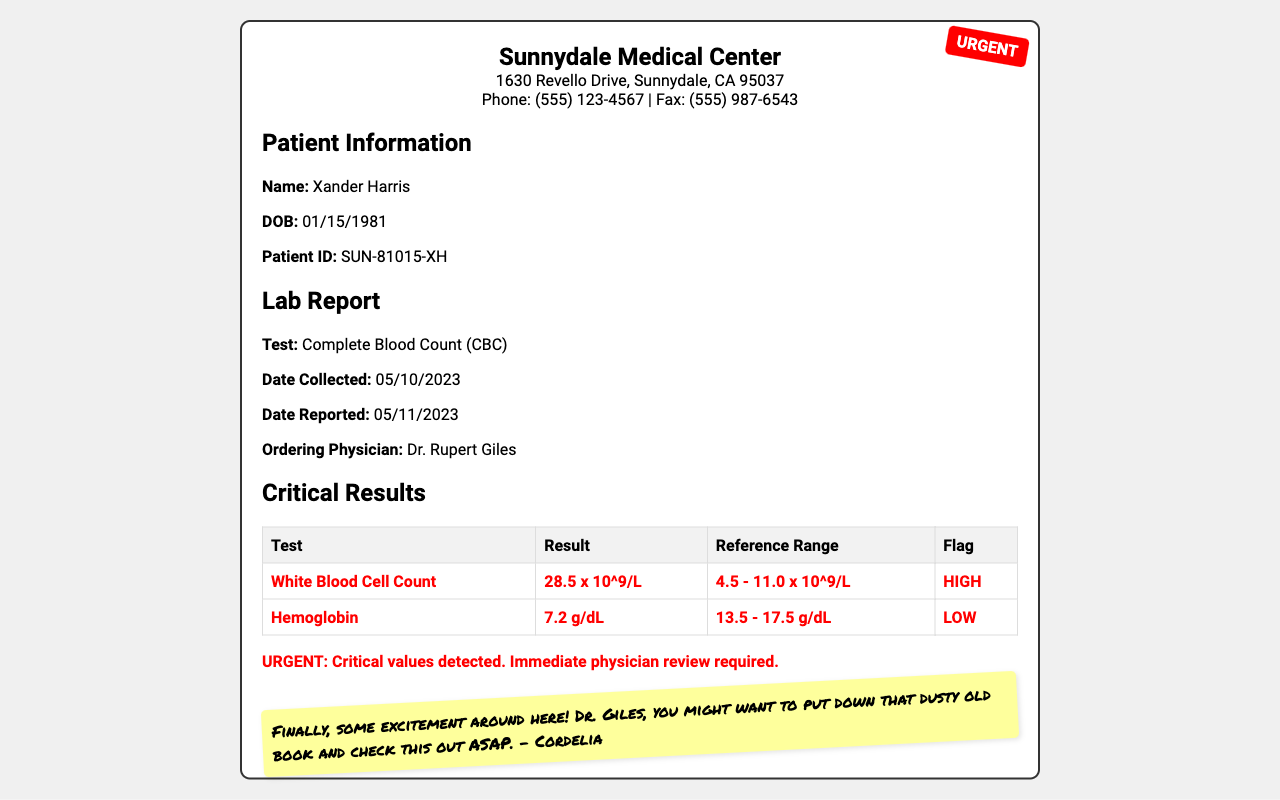What is the clinic's name? The clinic's name is prominently displayed at the top of the document.
Answer: Sunnydale Medical Center Who is the patient? The patient's name can be found in the patient information section.
Answer: Xander Harris What is the date the sample was collected? The collection date is listed in the lab report section.
Answer: 05/10/2023 What is the result for the White Blood Cell Count? The results for each test are detailed in the critical results table.
Answer: 28.5 x 10^9/L What flag is associated with the Hemoglobin test? The flag for Hemoglobin can be found in the table showing critical results.
Answer: LOW What is the urgency of the report? The urgency is indicated in the urgent stamp and in the text on the document.
Answer: URGENT Which physician ordered the lab tests? The ordering physician’s name is provided in the lab report section.
Answer: Dr. Rupert Giles What is on the sticky note? The sticky note contains a message that adds context to the urgency of the report.
Answer: Finally, some excitement around here! What critical value is indicated as HIGH? The critical results table lists the values with flags.
Answer: White Blood Cell Count 